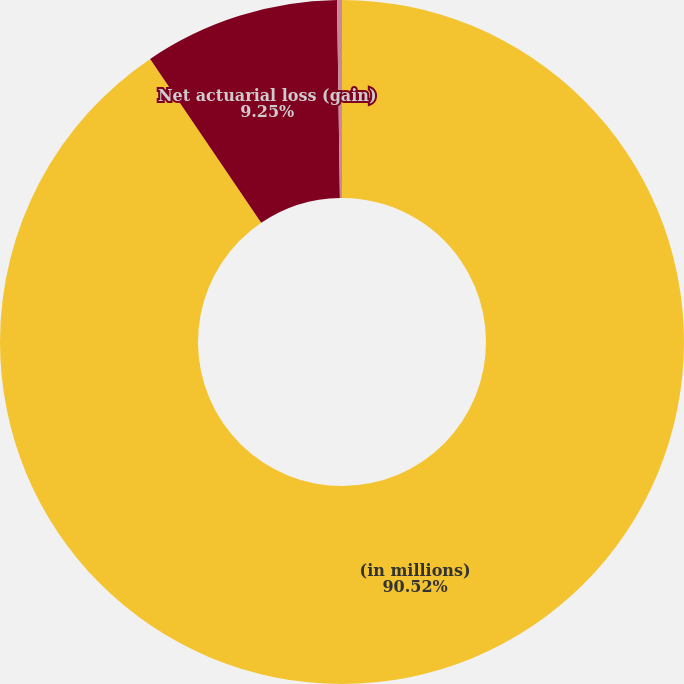Convert chart to OTSL. <chart><loc_0><loc_0><loc_500><loc_500><pie_chart><fcel>(in millions)<fcel>Net actuarial loss (gain)<fcel>Total recognized<nl><fcel>90.52%<fcel>9.25%<fcel>0.23%<nl></chart> 